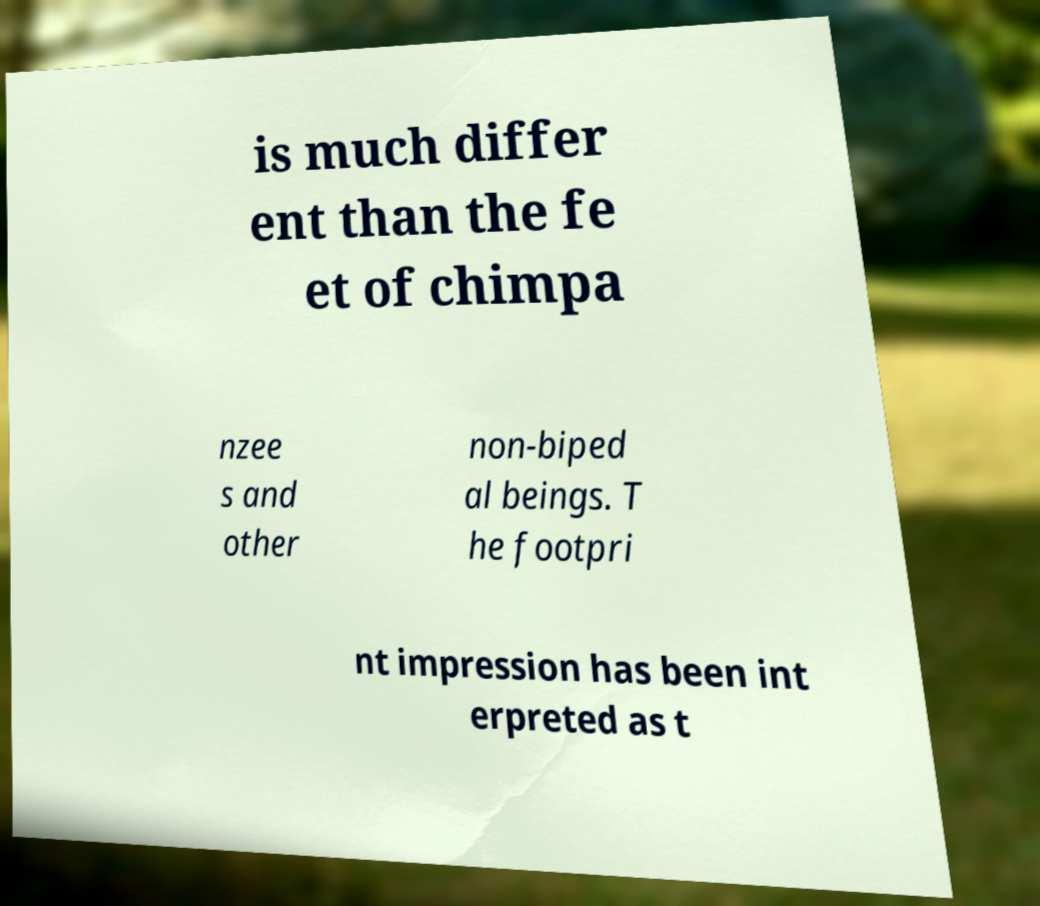I need the written content from this picture converted into text. Can you do that? is much differ ent than the fe et of chimpa nzee s and other non-biped al beings. T he footpri nt impression has been int erpreted as t 